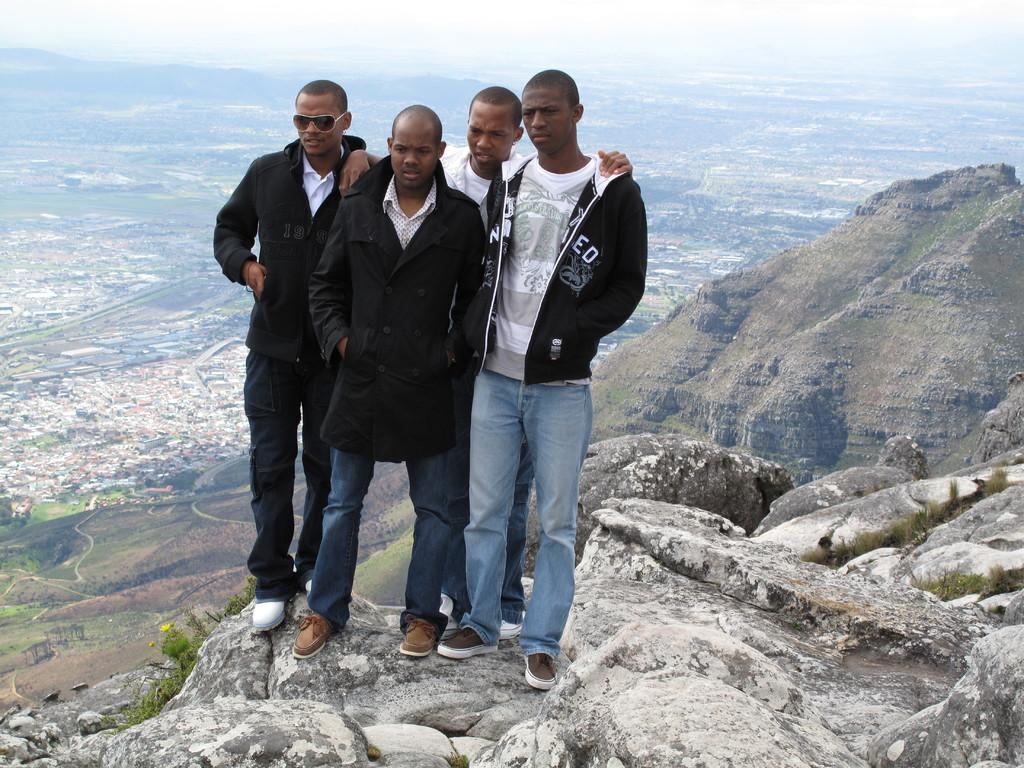How many people are in the image? There are four men in the image. Can you describe any specific clothing or accessories worn by one of the men? One of the men is wearing shades. What can be seen in the background of the image? There are buildings, mountains, and the sky visible in the background of the image. What type of rifle is being used by one of the men in the image? There is no rifle present in the image; it features four men without any weapons. What thrilling activity are the men participating in, as seen in the image? The image does not depict any specific activity or thrill; it simply shows four men and the background. 